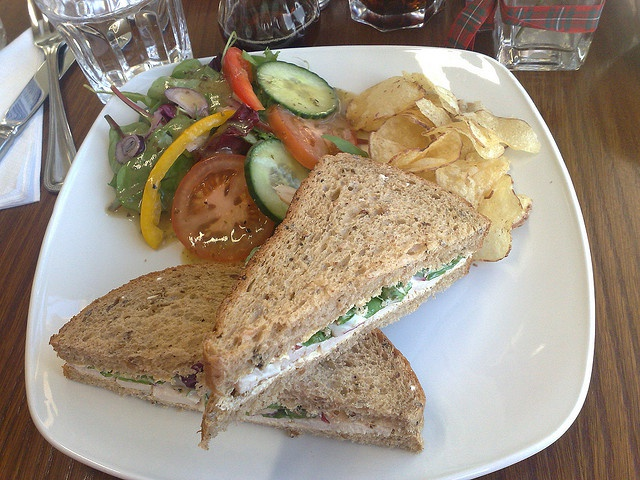Describe the objects in this image and their specific colors. I can see dining table in lightgray, darkgray, gray, and maroon tones, sandwich in gray and tan tones, sandwich in gray, tan, maroon, and darkgray tones, cup in gray, darkgray, and white tones, and cup in gray, brown, and darkgray tones in this image. 